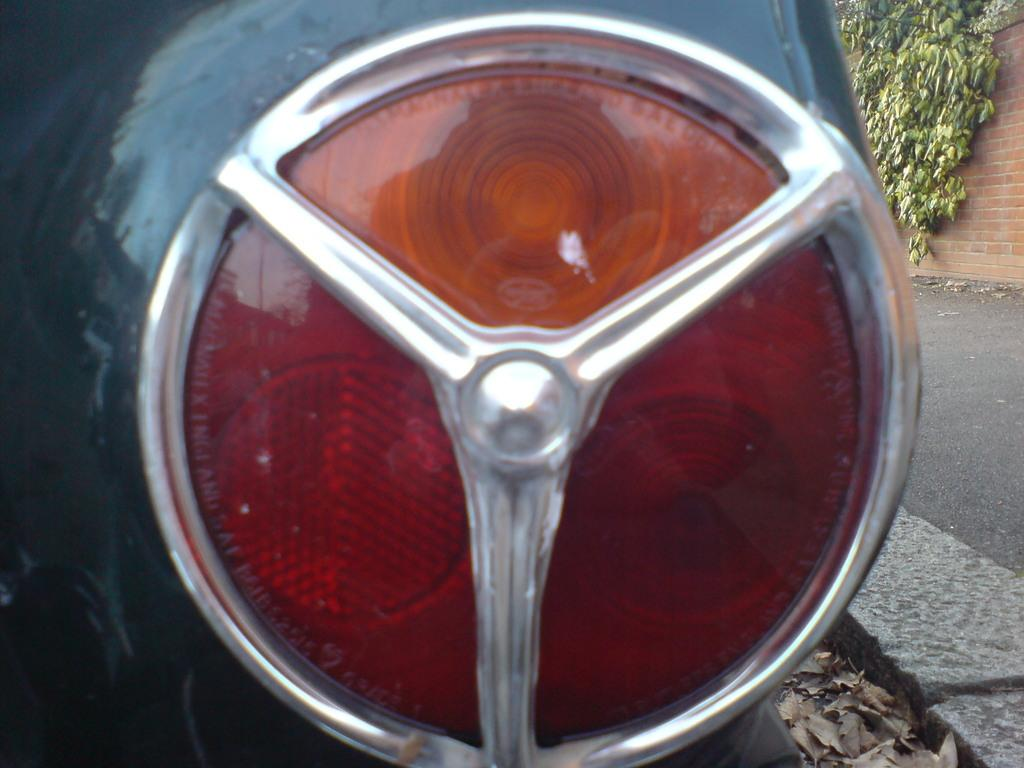What type of vehicle is in the image? There is a vehicle with a light in the image. What is on the right side of the image? There is a pavement on the right side of the image. What is growing on the wall in the image? There is a wall with creepers in the image. What can be seen near the pavement? There are dried leaves beside the pavement. How many ladybugs are crawling on the wrist of the person in the image? There is no person or ladybug present in the image. 